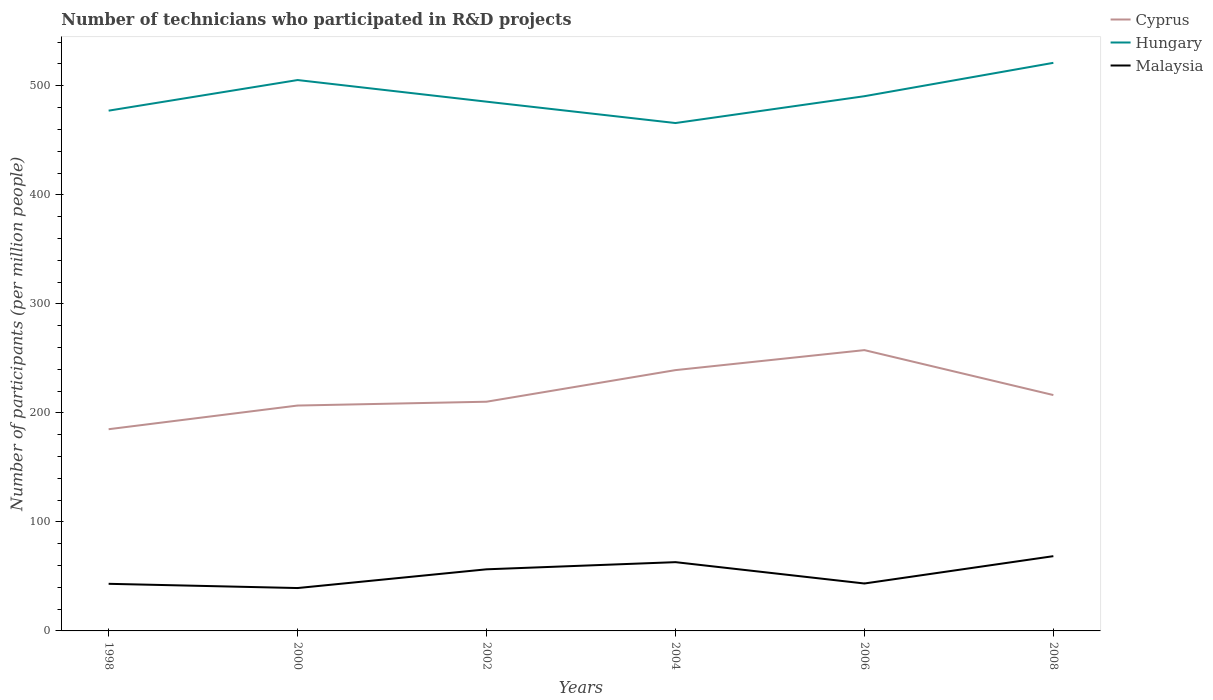Is the number of lines equal to the number of legend labels?
Provide a short and direct response. Yes. Across all years, what is the maximum number of technicians who participated in R&D projects in Hungary?
Keep it short and to the point. 465.84. In which year was the number of technicians who participated in R&D projects in Cyprus maximum?
Provide a succinct answer. 1998. What is the total number of technicians who participated in R&D projects in Cyprus in the graph?
Your response must be concise. -25.22. What is the difference between the highest and the second highest number of technicians who participated in R&D projects in Cyprus?
Give a very brief answer. 72.55. What is the difference between the highest and the lowest number of technicians who participated in R&D projects in Hungary?
Provide a short and direct response. 2. Is the number of technicians who participated in R&D projects in Cyprus strictly greater than the number of technicians who participated in R&D projects in Malaysia over the years?
Your response must be concise. No. How many lines are there?
Your answer should be very brief. 3. What is the difference between two consecutive major ticks on the Y-axis?
Provide a short and direct response. 100. Are the values on the major ticks of Y-axis written in scientific E-notation?
Offer a very short reply. No. Where does the legend appear in the graph?
Make the answer very short. Top right. How many legend labels are there?
Your response must be concise. 3. How are the legend labels stacked?
Provide a short and direct response. Vertical. What is the title of the graph?
Provide a succinct answer. Number of technicians who participated in R&D projects. What is the label or title of the X-axis?
Keep it short and to the point. Years. What is the label or title of the Y-axis?
Ensure brevity in your answer.  Number of participants (per million people). What is the Number of participants (per million people) in Cyprus in 1998?
Offer a terse response. 185.01. What is the Number of participants (per million people) in Hungary in 1998?
Ensure brevity in your answer.  477.2. What is the Number of participants (per million people) in Malaysia in 1998?
Your answer should be very brief. 43.21. What is the Number of participants (per million people) in Cyprus in 2000?
Make the answer very short. 206.72. What is the Number of participants (per million people) in Hungary in 2000?
Provide a succinct answer. 505.28. What is the Number of participants (per million people) in Malaysia in 2000?
Keep it short and to the point. 39.32. What is the Number of participants (per million people) of Cyprus in 2002?
Ensure brevity in your answer.  210.23. What is the Number of participants (per million people) in Hungary in 2002?
Provide a short and direct response. 485.44. What is the Number of participants (per million people) of Malaysia in 2002?
Your answer should be compact. 56.51. What is the Number of participants (per million people) in Cyprus in 2004?
Provide a succinct answer. 239.21. What is the Number of participants (per million people) in Hungary in 2004?
Offer a very short reply. 465.84. What is the Number of participants (per million people) in Malaysia in 2004?
Provide a succinct answer. 63.07. What is the Number of participants (per million people) of Cyprus in 2006?
Give a very brief answer. 257.56. What is the Number of participants (per million people) of Hungary in 2006?
Offer a terse response. 490.45. What is the Number of participants (per million people) in Malaysia in 2006?
Your answer should be compact. 43.5. What is the Number of participants (per million people) of Cyprus in 2008?
Keep it short and to the point. 216.34. What is the Number of participants (per million people) of Hungary in 2008?
Give a very brief answer. 521.06. What is the Number of participants (per million people) in Malaysia in 2008?
Provide a short and direct response. 68.57. Across all years, what is the maximum Number of participants (per million people) of Cyprus?
Your response must be concise. 257.56. Across all years, what is the maximum Number of participants (per million people) of Hungary?
Keep it short and to the point. 521.06. Across all years, what is the maximum Number of participants (per million people) of Malaysia?
Provide a succinct answer. 68.57. Across all years, what is the minimum Number of participants (per million people) in Cyprus?
Provide a short and direct response. 185.01. Across all years, what is the minimum Number of participants (per million people) in Hungary?
Your answer should be very brief. 465.84. Across all years, what is the minimum Number of participants (per million people) of Malaysia?
Offer a very short reply. 39.32. What is the total Number of participants (per million people) in Cyprus in the graph?
Provide a short and direct response. 1315.08. What is the total Number of participants (per million people) of Hungary in the graph?
Provide a short and direct response. 2945.26. What is the total Number of participants (per million people) of Malaysia in the graph?
Make the answer very short. 314.19. What is the difference between the Number of participants (per million people) of Cyprus in 1998 and that in 2000?
Your answer should be compact. -21.71. What is the difference between the Number of participants (per million people) of Hungary in 1998 and that in 2000?
Keep it short and to the point. -28.08. What is the difference between the Number of participants (per million people) in Malaysia in 1998 and that in 2000?
Your answer should be compact. 3.88. What is the difference between the Number of participants (per million people) of Cyprus in 1998 and that in 2002?
Provide a succinct answer. -25.22. What is the difference between the Number of participants (per million people) of Hungary in 1998 and that in 2002?
Your answer should be compact. -8.24. What is the difference between the Number of participants (per million people) of Malaysia in 1998 and that in 2002?
Offer a terse response. -13.31. What is the difference between the Number of participants (per million people) of Cyprus in 1998 and that in 2004?
Your answer should be compact. -54.2. What is the difference between the Number of participants (per million people) of Hungary in 1998 and that in 2004?
Keep it short and to the point. 11.36. What is the difference between the Number of participants (per million people) in Malaysia in 1998 and that in 2004?
Ensure brevity in your answer.  -19.87. What is the difference between the Number of participants (per million people) of Cyprus in 1998 and that in 2006?
Your response must be concise. -72.55. What is the difference between the Number of participants (per million people) of Hungary in 1998 and that in 2006?
Make the answer very short. -13.25. What is the difference between the Number of participants (per million people) in Malaysia in 1998 and that in 2006?
Offer a terse response. -0.29. What is the difference between the Number of participants (per million people) in Cyprus in 1998 and that in 2008?
Your answer should be compact. -31.33. What is the difference between the Number of participants (per million people) of Hungary in 1998 and that in 2008?
Keep it short and to the point. -43.86. What is the difference between the Number of participants (per million people) in Malaysia in 1998 and that in 2008?
Your answer should be compact. -25.37. What is the difference between the Number of participants (per million people) of Cyprus in 2000 and that in 2002?
Your response must be concise. -3.51. What is the difference between the Number of participants (per million people) in Hungary in 2000 and that in 2002?
Ensure brevity in your answer.  19.84. What is the difference between the Number of participants (per million people) of Malaysia in 2000 and that in 2002?
Offer a very short reply. -17.19. What is the difference between the Number of participants (per million people) in Cyprus in 2000 and that in 2004?
Your response must be concise. -32.49. What is the difference between the Number of participants (per million people) of Hungary in 2000 and that in 2004?
Your answer should be compact. 39.44. What is the difference between the Number of participants (per million people) in Malaysia in 2000 and that in 2004?
Your answer should be compact. -23.75. What is the difference between the Number of participants (per million people) of Cyprus in 2000 and that in 2006?
Offer a very short reply. -50.84. What is the difference between the Number of participants (per million people) in Hungary in 2000 and that in 2006?
Offer a terse response. 14.82. What is the difference between the Number of participants (per million people) in Malaysia in 2000 and that in 2006?
Offer a terse response. -4.17. What is the difference between the Number of participants (per million people) of Cyprus in 2000 and that in 2008?
Provide a short and direct response. -9.62. What is the difference between the Number of participants (per million people) in Hungary in 2000 and that in 2008?
Provide a short and direct response. -15.78. What is the difference between the Number of participants (per million people) in Malaysia in 2000 and that in 2008?
Ensure brevity in your answer.  -29.25. What is the difference between the Number of participants (per million people) in Cyprus in 2002 and that in 2004?
Offer a terse response. -28.98. What is the difference between the Number of participants (per million people) of Hungary in 2002 and that in 2004?
Offer a terse response. 19.6. What is the difference between the Number of participants (per million people) in Malaysia in 2002 and that in 2004?
Offer a very short reply. -6.56. What is the difference between the Number of participants (per million people) in Cyprus in 2002 and that in 2006?
Your response must be concise. -47.33. What is the difference between the Number of participants (per million people) of Hungary in 2002 and that in 2006?
Make the answer very short. -5.01. What is the difference between the Number of participants (per million people) of Malaysia in 2002 and that in 2006?
Provide a succinct answer. 13.01. What is the difference between the Number of participants (per million people) in Cyprus in 2002 and that in 2008?
Your response must be concise. -6.11. What is the difference between the Number of participants (per million people) of Hungary in 2002 and that in 2008?
Provide a short and direct response. -35.62. What is the difference between the Number of participants (per million people) of Malaysia in 2002 and that in 2008?
Make the answer very short. -12.06. What is the difference between the Number of participants (per million people) of Cyprus in 2004 and that in 2006?
Keep it short and to the point. -18.35. What is the difference between the Number of participants (per million people) of Hungary in 2004 and that in 2006?
Provide a short and direct response. -24.61. What is the difference between the Number of participants (per million people) of Malaysia in 2004 and that in 2006?
Keep it short and to the point. 19.58. What is the difference between the Number of participants (per million people) of Cyprus in 2004 and that in 2008?
Provide a short and direct response. 22.87. What is the difference between the Number of participants (per million people) of Hungary in 2004 and that in 2008?
Provide a succinct answer. -55.22. What is the difference between the Number of participants (per million people) of Malaysia in 2004 and that in 2008?
Your response must be concise. -5.5. What is the difference between the Number of participants (per million people) of Cyprus in 2006 and that in 2008?
Give a very brief answer. 41.22. What is the difference between the Number of participants (per million people) of Hungary in 2006 and that in 2008?
Provide a short and direct response. -30.61. What is the difference between the Number of participants (per million people) in Malaysia in 2006 and that in 2008?
Give a very brief answer. -25.08. What is the difference between the Number of participants (per million people) in Cyprus in 1998 and the Number of participants (per million people) in Hungary in 2000?
Your answer should be very brief. -320.26. What is the difference between the Number of participants (per million people) of Cyprus in 1998 and the Number of participants (per million people) of Malaysia in 2000?
Keep it short and to the point. 145.69. What is the difference between the Number of participants (per million people) in Hungary in 1998 and the Number of participants (per million people) in Malaysia in 2000?
Ensure brevity in your answer.  437.87. What is the difference between the Number of participants (per million people) in Cyprus in 1998 and the Number of participants (per million people) in Hungary in 2002?
Offer a very short reply. -300.43. What is the difference between the Number of participants (per million people) in Cyprus in 1998 and the Number of participants (per million people) in Malaysia in 2002?
Your answer should be compact. 128.5. What is the difference between the Number of participants (per million people) of Hungary in 1998 and the Number of participants (per million people) of Malaysia in 2002?
Your answer should be compact. 420.69. What is the difference between the Number of participants (per million people) in Cyprus in 1998 and the Number of participants (per million people) in Hungary in 2004?
Give a very brief answer. -280.83. What is the difference between the Number of participants (per million people) of Cyprus in 1998 and the Number of participants (per million people) of Malaysia in 2004?
Make the answer very short. 121.94. What is the difference between the Number of participants (per million people) of Hungary in 1998 and the Number of participants (per million people) of Malaysia in 2004?
Your answer should be very brief. 414.12. What is the difference between the Number of participants (per million people) in Cyprus in 1998 and the Number of participants (per million people) in Hungary in 2006?
Make the answer very short. -305.44. What is the difference between the Number of participants (per million people) in Cyprus in 1998 and the Number of participants (per million people) in Malaysia in 2006?
Your answer should be very brief. 141.52. What is the difference between the Number of participants (per million people) in Hungary in 1998 and the Number of participants (per million people) in Malaysia in 2006?
Offer a very short reply. 433.7. What is the difference between the Number of participants (per million people) of Cyprus in 1998 and the Number of participants (per million people) of Hungary in 2008?
Provide a succinct answer. -336.04. What is the difference between the Number of participants (per million people) of Cyprus in 1998 and the Number of participants (per million people) of Malaysia in 2008?
Give a very brief answer. 116.44. What is the difference between the Number of participants (per million people) of Hungary in 1998 and the Number of participants (per million people) of Malaysia in 2008?
Provide a short and direct response. 408.62. What is the difference between the Number of participants (per million people) in Cyprus in 2000 and the Number of participants (per million people) in Hungary in 2002?
Your answer should be very brief. -278.72. What is the difference between the Number of participants (per million people) of Cyprus in 2000 and the Number of participants (per million people) of Malaysia in 2002?
Offer a terse response. 150.21. What is the difference between the Number of participants (per million people) in Hungary in 2000 and the Number of participants (per million people) in Malaysia in 2002?
Your answer should be compact. 448.76. What is the difference between the Number of participants (per million people) of Cyprus in 2000 and the Number of participants (per million people) of Hungary in 2004?
Ensure brevity in your answer.  -259.12. What is the difference between the Number of participants (per million people) of Cyprus in 2000 and the Number of participants (per million people) of Malaysia in 2004?
Your response must be concise. 143.65. What is the difference between the Number of participants (per million people) in Hungary in 2000 and the Number of participants (per million people) in Malaysia in 2004?
Keep it short and to the point. 442.2. What is the difference between the Number of participants (per million people) of Cyprus in 2000 and the Number of participants (per million people) of Hungary in 2006?
Offer a very short reply. -283.73. What is the difference between the Number of participants (per million people) of Cyprus in 2000 and the Number of participants (per million people) of Malaysia in 2006?
Your response must be concise. 163.23. What is the difference between the Number of participants (per million people) in Hungary in 2000 and the Number of participants (per million people) in Malaysia in 2006?
Provide a succinct answer. 461.78. What is the difference between the Number of participants (per million people) in Cyprus in 2000 and the Number of participants (per million people) in Hungary in 2008?
Make the answer very short. -314.33. What is the difference between the Number of participants (per million people) of Cyprus in 2000 and the Number of participants (per million people) of Malaysia in 2008?
Your answer should be very brief. 138.15. What is the difference between the Number of participants (per million people) of Hungary in 2000 and the Number of participants (per million people) of Malaysia in 2008?
Provide a succinct answer. 436.7. What is the difference between the Number of participants (per million people) of Cyprus in 2002 and the Number of participants (per million people) of Hungary in 2004?
Offer a terse response. -255.61. What is the difference between the Number of participants (per million people) of Cyprus in 2002 and the Number of participants (per million people) of Malaysia in 2004?
Offer a very short reply. 147.15. What is the difference between the Number of participants (per million people) of Hungary in 2002 and the Number of participants (per million people) of Malaysia in 2004?
Provide a short and direct response. 422.37. What is the difference between the Number of participants (per million people) of Cyprus in 2002 and the Number of participants (per million people) of Hungary in 2006?
Your answer should be very brief. -280.22. What is the difference between the Number of participants (per million people) in Cyprus in 2002 and the Number of participants (per million people) in Malaysia in 2006?
Offer a terse response. 166.73. What is the difference between the Number of participants (per million people) in Hungary in 2002 and the Number of participants (per million people) in Malaysia in 2006?
Your answer should be very brief. 441.94. What is the difference between the Number of participants (per million people) of Cyprus in 2002 and the Number of participants (per million people) of Hungary in 2008?
Provide a short and direct response. -310.83. What is the difference between the Number of participants (per million people) of Cyprus in 2002 and the Number of participants (per million people) of Malaysia in 2008?
Your response must be concise. 141.65. What is the difference between the Number of participants (per million people) in Hungary in 2002 and the Number of participants (per million people) in Malaysia in 2008?
Your answer should be compact. 416.86. What is the difference between the Number of participants (per million people) of Cyprus in 2004 and the Number of participants (per million people) of Hungary in 2006?
Your answer should be compact. -251.24. What is the difference between the Number of participants (per million people) of Cyprus in 2004 and the Number of participants (per million people) of Malaysia in 2006?
Your answer should be compact. 195.72. What is the difference between the Number of participants (per million people) of Hungary in 2004 and the Number of participants (per million people) of Malaysia in 2006?
Your answer should be very brief. 422.34. What is the difference between the Number of participants (per million people) of Cyprus in 2004 and the Number of participants (per million people) of Hungary in 2008?
Offer a very short reply. -281.84. What is the difference between the Number of participants (per million people) of Cyprus in 2004 and the Number of participants (per million people) of Malaysia in 2008?
Offer a terse response. 170.64. What is the difference between the Number of participants (per million people) in Hungary in 2004 and the Number of participants (per million people) in Malaysia in 2008?
Ensure brevity in your answer.  397.26. What is the difference between the Number of participants (per million people) of Cyprus in 2006 and the Number of participants (per million people) of Hungary in 2008?
Offer a terse response. -263.5. What is the difference between the Number of participants (per million people) of Cyprus in 2006 and the Number of participants (per million people) of Malaysia in 2008?
Give a very brief answer. 188.99. What is the difference between the Number of participants (per million people) of Hungary in 2006 and the Number of participants (per million people) of Malaysia in 2008?
Your response must be concise. 421.88. What is the average Number of participants (per million people) in Cyprus per year?
Ensure brevity in your answer.  219.18. What is the average Number of participants (per million people) of Hungary per year?
Your answer should be compact. 490.88. What is the average Number of participants (per million people) in Malaysia per year?
Give a very brief answer. 52.36. In the year 1998, what is the difference between the Number of participants (per million people) of Cyprus and Number of participants (per million people) of Hungary?
Ensure brevity in your answer.  -292.18. In the year 1998, what is the difference between the Number of participants (per million people) of Cyprus and Number of participants (per million people) of Malaysia?
Offer a terse response. 141.81. In the year 1998, what is the difference between the Number of participants (per million people) of Hungary and Number of participants (per million people) of Malaysia?
Offer a very short reply. 433.99. In the year 2000, what is the difference between the Number of participants (per million people) in Cyprus and Number of participants (per million people) in Hungary?
Your response must be concise. -298.55. In the year 2000, what is the difference between the Number of participants (per million people) of Cyprus and Number of participants (per million people) of Malaysia?
Your response must be concise. 167.4. In the year 2000, what is the difference between the Number of participants (per million people) of Hungary and Number of participants (per million people) of Malaysia?
Provide a succinct answer. 465.95. In the year 2002, what is the difference between the Number of participants (per million people) in Cyprus and Number of participants (per million people) in Hungary?
Offer a terse response. -275.21. In the year 2002, what is the difference between the Number of participants (per million people) of Cyprus and Number of participants (per million people) of Malaysia?
Your response must be concise. 153.72. In the year 2002, what is the difference between the Number of participants (per million people) of Hungary and Number of participants (per million people) of Malaysia?
Keep it short and to the point. 428.93. In the year 2004, what is the difference between the Number of participants (per million people) in Cyprus and Number of participants (per million people) in Hungary?
Ensure brevity in your answer.  -226.63. In the year 2004, what is the difference between the Number of participants (per million people) of Cyprus and Number of participants (per million people) of Malaysia?
Provide a short and direct response. 176.14. In the year 2004, what is the difference between the Number of participants (per million people) of Hungary and Number of participants (per million people) of Malaysia?
Offer a terse response. 402.77. In the year 2006, what is the difference between the Number of participants (per million people) in Cyprus and Number of participants (per million people) in Hungary?
Your answer should be very brief. -232.89. In the year 2006, what is the difference between the Number of participants (per million people) in Cyprus and Number of participants (per million people) in Malaysia?
Offer a very short reply. 214.06. In the year 2006, what is the difference between the Number of participants (per million people) in Hungary and Number of participants (per million people) in Malaysia?
Provide a succinct answer. 446.95. In the year 2008, what is the difference between the Number of participants (per million people) of Cyprus and Number of participants (per million people) of Hungary?
Give a very brief answer. -304.72. In the year 2008, what is the difference between the Number of participants (per million people) in Cyprus and Number of participants (per million people) in Malaysia?
Provide a succinct answer. 147.76. In the year 2008, what is the difference between the Number of participants (per million people) in Hungary and Number of participants (per million people) in Malaysia?
Your answer should be compact. 452.48. What is the ratio of the Number of participants (per million people) of Cyprus in 1998 to that in 2000?
Offer a terse response. 0.9. What is the ratio of the Number of participants (per million people) of Hungary in 1998 to that in 2000?
Offer a very short reply. 0.94. What is the ratio of the Number of participants (per million people) of Malaysia in 1998 to that in 2000?
Make the answer very short. 1.1. What is the ratio of the Number of participants (per million people) of Cyprus in 1998 to that in 2002?
Your answer should be very brief. 0.88. What is the ratio of the Number of participants (per million people) of Malaysia in 1998 to that in 2002?
Ensure brevity in your answer.  0.76. What is the ratio of the Number of participants (per million people) of Cyprus in 1998 to that in 2004?
Give a very brief answer. 0.77. What is the ratio of the Number of participants (per million people) in Hungary in 1998 to that in 2004?
Your response must be concise. 1.02. What is the ratio of the Number of participants (per million people) in Malaysia in 1998 to that in 2004?
Give a very brief answer. 0.69. What is the ratio of the Number of participants (per million people) of Cyprus in 1998 to that in 2006?
Your response must be concise. 0.72. What is the ratio of the Number of participants (per million people) in Hungary in 1998 to that in 2006?
Keep it short and to the point. 0.97. What is the ratio of the Number of participants (per million people) in Cyprus in 1998 to that in 2008?
Provide a succinct answer. 0.86. What is the ratio of the Number of participants (per million people) of Hungary in 1998 to that in 2008?
Your response must be concise. 0.92. What is the ratio of the Number of participants (per million people) of Malaysia in 1998 to that in 2008?
Ensure brevity in your answer.  0.63. What is the ratio of the Number of participants (per million people) of Cyprus in 2000 to that in 2002?
Provide a succinct answer. 0.98. What is the ratio of the Number of participants (per million people) of Hungary in 2000 to that in 2002?
Offer a very short reply. 1.04. What is the ratio of the Number of participants (per million people) in Malaysia in 2000 to that in 2002?
Your answer should be very brief. 0.7. What is the ratio of the Number of participants (per million people) of Cyprus in 2000 to that in 2004?
Offer a terse response. 0.86. What is the ratio of the Number of participants (per million people) in Hungary in 2000 to that in 2004?
Provide a short and direct response. 1.08. What is the ratio of the Number of participants (per million people) in Malaysia in 2000 to that in 2004?
Offer a very short reply. 0.62. What is the ratio of the Number of participants (per million people) in Cyprus in 2000 to that in 2006?
Provide a succinct answer. 0.8. What is the ratio of the Number of participants (per million people) of Hungary in 2000 to that in 2006?
Your answer should be very brief. 1.03. What is the ratio of the Number of participants (per million people) in Malaysia in 2000 to that in 2006?
Offer a very short reply. 0.9. What is the ratio of the Number of participants (per million people) of Cyprus in 2000 to that in 2008?
Provide a short and direct response. 0.96. What is the ratio of the Number of participants (per million people) in Hungary in 2000 to that in 2008?
Your answer should be very brief. 0.97. What is the ratio of the Number of participants (per million people) of Malaysia in 2000 to that in 2008?
Your response must be concise. 0.57. What is the ratio of the Number of participants (per million people) of Cyprus in 2002 to that in 2004?
Your answer should be very brief. 0.88. What is the ratio of the Number of participants (per million people) in Hungary in 2002 to that in 2004?
Ensure brevity in your answer.  1.04. What is the ratio of the Number of participants (per million people) in Malaysia in 2002 to that in 2004?
Provide a succinct answer. 0.9. What is the ratio of the Number of participants (per million people) of Cyprus in 2002 to that in 2006?
Provide a succinct answer. 0.82. What is the ratio of the Number of participants (per million people) of Malaysia in 2002 to that in 2006?
Ensure brevity in your answer.  1.3. What is the ratio of the Number of participants (per million people) of Cyprus in 2002 to that in 2008?
Provide a succinct answer. 0.97. What is the ratio of the Number of participants (per million people) in Hungary in 2002 to that in 2008?
Make the answer very short. 0.93. What is the ratio of the Number of participants (per million people) in Malaysia in 2002 to that in 2008?
Offer a terse response. 0.82. What is the ratio of the Number of participants (per million people) in Cyprus in 2004 to that in 2006?
Give a very brief answer. 0.93. What is the ratio of the Number of participants (per million people) of Hungary in 2004 to that in 2006?
Keep it short and to the point. 0.95. What is the ratio of the Number of participants (per million people) in Malaysia in 2004 to that in 2006?
Make the answer very short. 1.45. What is the ratio of the Number of participants (per million people) in Cyprus in 2004 to that in 2008?
Ensure brevity in your answer.  1.11. What is the ratio of the Number of participants (per million people) of Hungary in 2004 to that in 2008?
Offer a terse response. 0.89. What is the ratio of the Number of participants (per million people) in Malaysia in 2004 to that in 2008?
Provide a short and direct response. 0.92. What is the ratio of the Number of participants (per million people) of Cyprus in 2006 to that in 2008?
Offer a terse response. 1.19. What is the ratio of the Number of participants (per million people) of Hungary in 2006 to that in 2008?
Ensure brevity in your answer.  0.94. What is the ratio of the Number of participants (per million people) in Malaysia in 2006 to that in 2008?
Make the answer very short. 0.63. What is the difference between the highest and the second highest Number of participants (per million people) in Cyprus?
Your answer should be very brief. 18.35. What is the difference between the highest and the second highest Number of participants (per million people) in Hungary?
Your answer should be compact. 15.78. What is the difference between the highest and the second highest Number of participants (per million people) of Malaysia?
Ensure brevity in your answer.  5.5. What is the difference between the highest and the lowest Number of participants (per million people) in Cyprus?
Your answer should be very brief. 72.55. What is the difference between the highest and the lowest Number of participants (per million people) of Hungary?
Offer a very short reply. 55.22. What is the difference between the highest and the lowest Number of participants (per million people) of Malaysia?
Your answer should be compact. 29.25. 